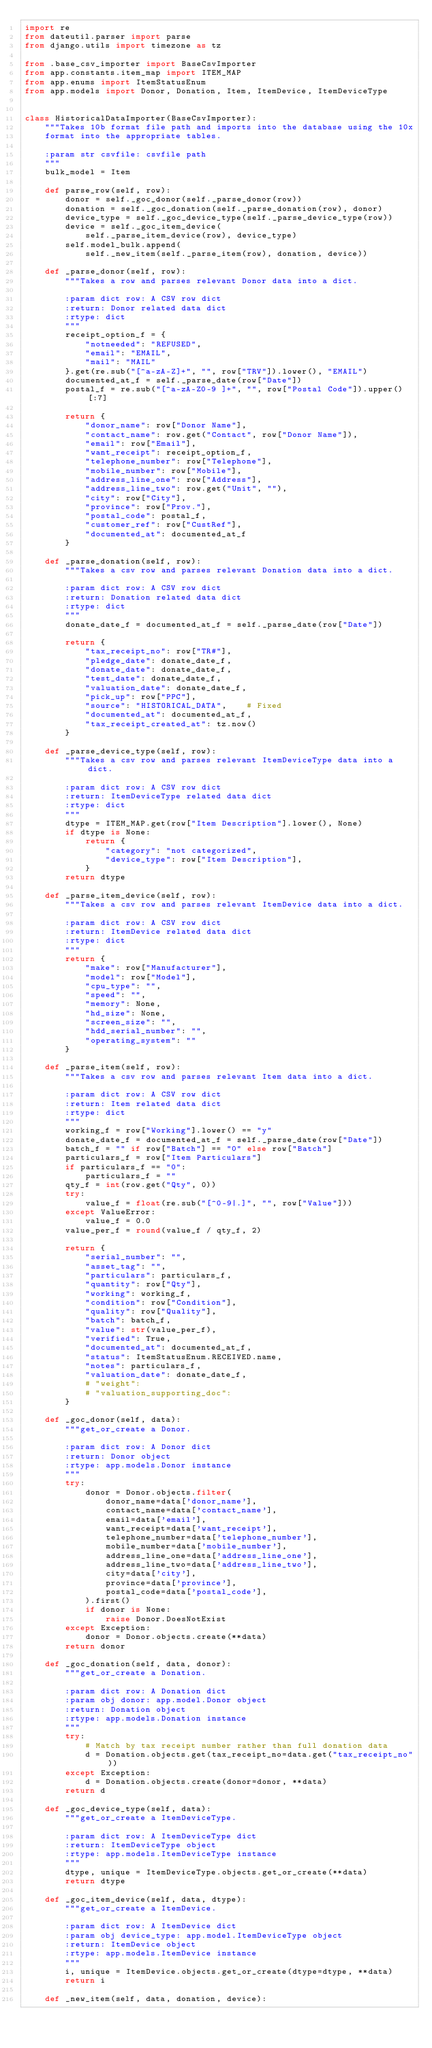Convert code to text. <code><loc_0><loc_0><loc_500><loc_500><_Python_>import re
from dateutil.parser import parse
from django.utils import timezone as tz

from .base_csv_importer import BaseCsvImporter
from app.constants.item_map import ITEM_MAP
from app.enums import ItemStatusEnum
from app.models import Donor, Donation, Item, ItemDevice, ItemDeviceType


class HistoricalDataImporter(BaseCsvImporter):
    """Takes 10b format file path and imports into the database using the 10x
    format into the appropriate tables.

    :param str csvfile: csvfile path
    """
    bulk_model = Item

    def parse_row(self, row):
        donor = self._goc_donor(self._parse_donor(row))
        donation = self._goc_donation(self._parse_donation(row), donor)
        device_type = self._goc_device_type(self._parse_device_type(row))
        device = self._goc_item_device(
            self._parse_item_device(row), device_type)
        self.model_bulk.append(
            self._new_item(self._parse_item(row), donation, device))

    def _parse_donor(self, row):
        """Takes a row and parses relevant Donor data into a dict.

        :param dict row: A CSV row dict
        :return: Donor related data dict
        :rtype: dict
        """
        receipt_option_f = {
            "notneeded": "REFUSED",
            "email": "EMAIL",
            "mail": "MAIL"
        }.get(re.sub("[^a-zA-Z]+", "", row["TRV"]).lower(), "EMAIL")
        documented_at_f = self._parse_date(row["Date"])
        postal_f = re.sub("[^a-zA-Z0-9 ]+", "", row["Postal Code"]).upper()[:7]

        return {
            "donor_name": row["Donor Name"],
            "contact_name": row.get("Contact", row["Donor Name"]),
            "email": row["Email"],
            "want_receipt": receipt_option_f,
            "telephone_number": row["Telephone"],
            "mobile_number": row["Mobile"],
            "address_line_one": row["Address"],
            "address_line_two": row.get("Unit", ""),
            "city": row["City"],
            "province": row["Prov."],
            "postal_code": postal_f,
            "customer_ref": row["CustRef"],
            "documented_at": documented_at_f
        }

    def _parse_donation(self, row):
        """Takes a csv row and parses relevant Donation data into a dict.

        :param dict row: A CSV row dict
        :return: Donation related data dict
        :rtype: dict
        """
        donate_date_f = documented_at_f = self._parse_date(row["Date"])

        return {
            "tax_receipt_no": row["TR#"],
            "pledge_date": donate_date_f,
            "donate_date": donate_date_f,
            "test_date": donate_date_f,
            "valuation_date": donate_date_f,
            "pick_up": row["PPC"],
            "source": "HISTORICAL_DATA",    # Fixed
            "documented_at": documented_at_f,
            "tax_receipt_created_at": tz.now()
        }

    def _parse_device_type(self, row):
        """Takes a csv row and parses relevant ItemDeviceType data into a dict.

        :param dict row: A CSV row dict
        :return: ItemDeviceType related data dict
        :rtype: dict
        """
        dtype = ITEM_MAP.get(row["Item Description"].lower(), None)
        if dtype is None:
            return {
                "category": "not categorized",
                "device_type": row["Item Description"],
            }
        return dtype

    def _parse_item_device(self, row):
        """Takes a csv row and parses relevant ItemDevice data into a dict.

        :param dict row: A CSV row dict
        :return: ItemDevice related data dict
        :rtype: dict
        """
        return {
            "make": row["Manufacturer"],
            "model": row["Model"],
            "cpu_type": "",
            "speed": "",
            "memory": None,
            "hd_size": None,
            "screen_size": "",
            "hdd_serial_number": "",
            "operating_system": ""
        }

    def _parse_item(self, row):
        """Takes a csv row and parses relevant Item data into a dict.

        :param dict row: A CSV row dict
        :return: Item related data dict
        :rtype: dict
        """
        working_f = row["Working"].lower() == "y"
        donate_date_f = documented_at_f = self._parse_date(row["Date"])
        batch_f = "" if row["Batch"] == "0" else row["Batch"]
        particulars_f = row["Item Particulars"]
        if particulars_f == "0":
            particulars_f = ""
        qty_f = int(row.get("Qty", 0))
        try:
            value_f = float(re.sub("[^0-9|.]", "", row["Value"]))
        except ValueError:
            value_f = 0.0
        value_per_f = round(value_f / qty_f, 2)

        return {
            "serial_number": "",
            "asset_tag": "",
            "particulars": particulars_f,
            "quantity": row["Qty"],
            "working": working_f,
            "condition": row["Condition"],
            "quality": row["Quality"],
            "batch": batch_f,
            "value": str(value_per_f),
            "verified": True,
            "documented_at": documented_at_f,
            "status": ItemStatusEnum.RECEIVED.name,
            "notes": particulars_f,
            "valuation_date": donate_date_f,
            # "weight":
            # "valuation_supporting_doc":
        }

    def _goc_donor(self, data):
        """get_or_create a Donor.

        :param dict row: A Donor dict
        :return: Donor object
        :rtype: app.models.Donor instance
        """
        try:
            donor = Donor.objects.filter(
                donor_name=data['donor_name'],
                contact_name=data['contact_name'],
                email=data['email'],
                want_receipt=data['want_receipt'],
                telephone_number=data['telephone_number'],
                mobile_number=data['mobile_number'],
                address_line_one=data['address_line_one'],
                address_line_two=data['address_line_two'],
                city=data['city'],
                province=data['province'],
                postal_code=data['postal_code'],
            ).first()
            if donor is None:
                raise Donor.DoesNotExist
        except Exception:
            donor = Donor.objects.create(**data)
        return donor

    def _goc_donation(self, data, donor):
        """get_or_create a Donation.

        :param dict row: A Donation dict
        :param obj donor: app.model.Donor object
        :return: Donation object
        :rtype: app.models.Donation instance
        """
        try:
            # Match by tax receipt number rather than full donation data
            d = Donation.objects.get(tax_receipt_no=data.get("tax_receipt_no"))
        except Exception:
            d = Donation.objects.create(donor=donor, **data)
        return d

    def _goc_device_type(self, data):
        """get_or_create a ItemDeviceType.

        :param dict row: A ItemDeviceType dict
        :return: ItemDeviceType object
        :rtype: app.models.ItemDeviceType instance
        """
        dtype, unique = ItemDeviceType.objects.get_or_create(**data)
        return dtype

    def _goc_item_device(self, data, dtype):
        """get_or_create a ItemDevice.

        :param dict row: A ItemDevice dict
        :param obj device_type: app.model.ItemDeviceType object
        :return: ItemDevice object
        :rtype: app.models.ItemDevice instance
        """
        i, unique = ItemDevice.objects.get_or_create(dtype=dtype, **data)
        return i

    def _new_item(self, data, donation, device):</code> 